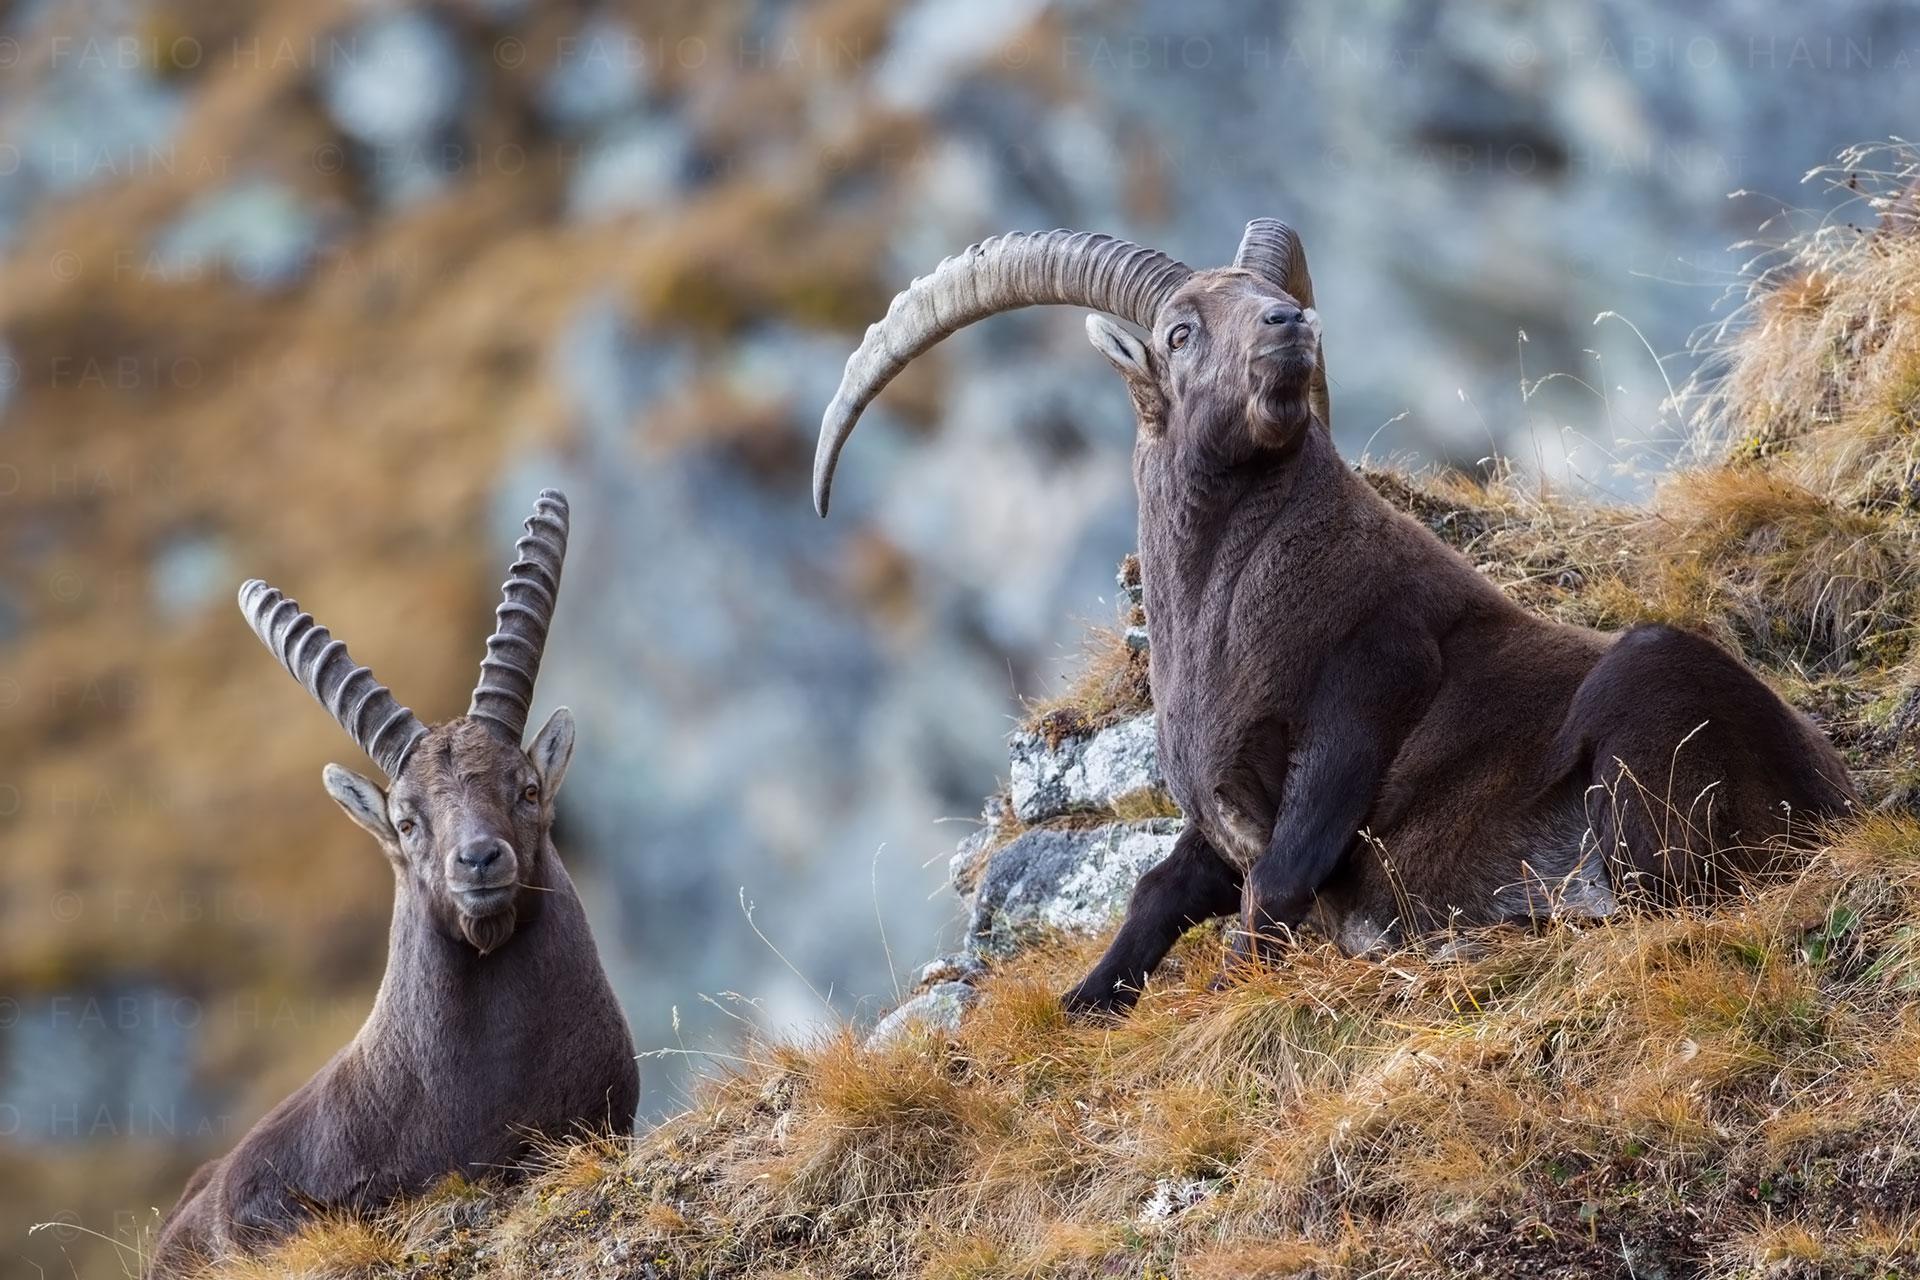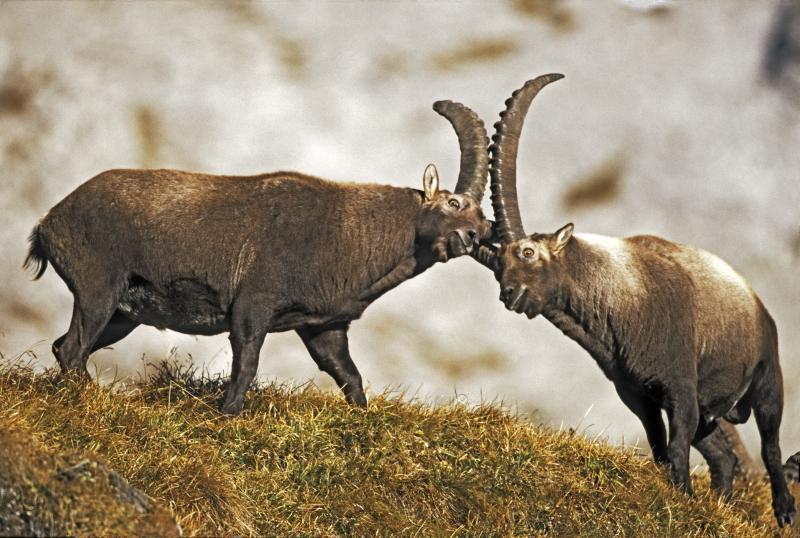The first image is the image on the left, the second image is the image on the right. For the images shown, is this caption "Exactly two horned animals are shown in their native habitat." true? Answer yes or no. No. The first image is the image on the left, the second image is the image on the right. Analyze the images presented: Is the assertion "One image shows two antelope, which are not butting heads." valid? Answer yes or no. Yes. 